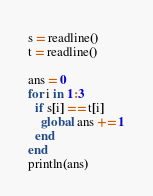Convert code to text. <code><loc_0><loc_0><loc_500><loc_500><_Julia_>s = readline()
t = readline()

ans = 0
for i in 1:3
  if s[i] == t[i]
    global ans += 1
  end
end
println(ans)</code> 